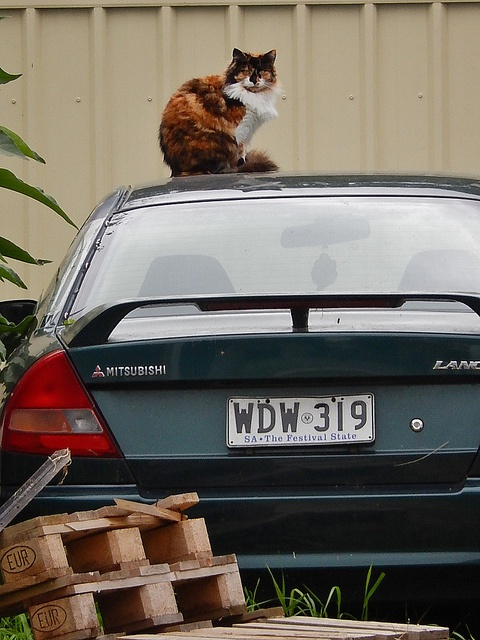Describe the objects in this image and their specific colors. I can see car in tan, black, lightgray, darkgray, and purple tones and cat in tan, black, maroon, darkgray, and brown tones in this image. 